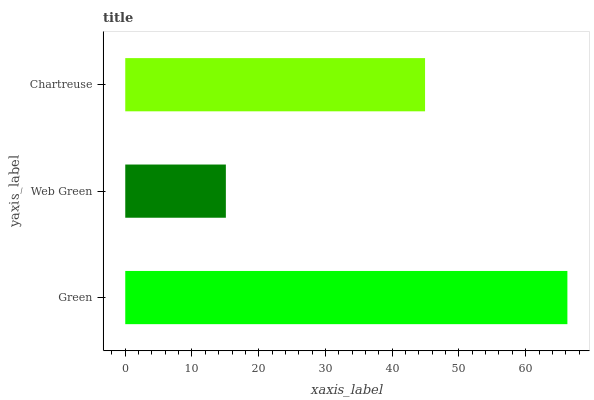Is Web Green the minimum?
Answer yes or no. Yes. Is Green the maximum?
Answer yes or no. Yes. Is Chartreuse the minimum?
Answer yes or no. No. Is Chartreuse the maximum?
Answer yes or no. No. Is Chartreuse greater than Web Green?
Answer yes or no. Yes. Is Web Green less than Chartreuse?
Answer yes or no. Yes. Is Web Green greater than Chartreuse?
Answer yes or no. No. Is Chartreuse less than Web Green?
Answer yes or no. No. Is Chartreuse the high median?
Answer yes or no. Yes. Is Chartreuse the low median?
Answer yes or no. Yes. Is Green the high median?
Answer yes or no. No. Is Web Green the low median?
Answer yes or no. No. 